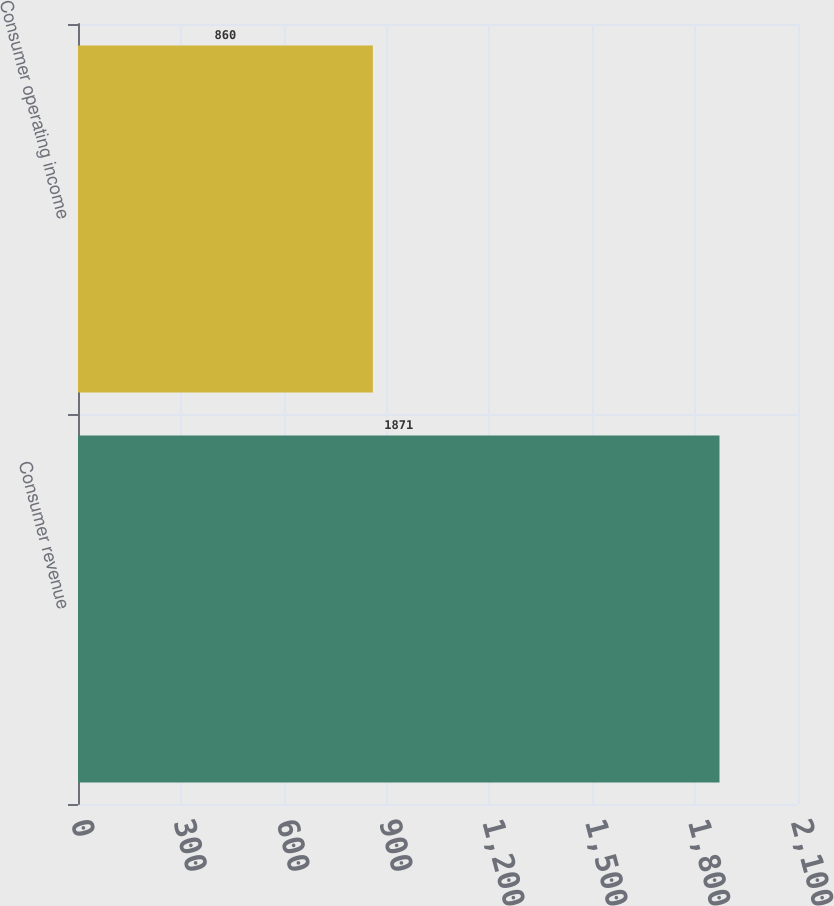<chart> <loc_0><loc_0><loc_500><loc_500><bar_chart><fcel>Consumer revenue<fcel>Consumer operating income<nl><fcel>1871<fcel>860<nl></chart> 